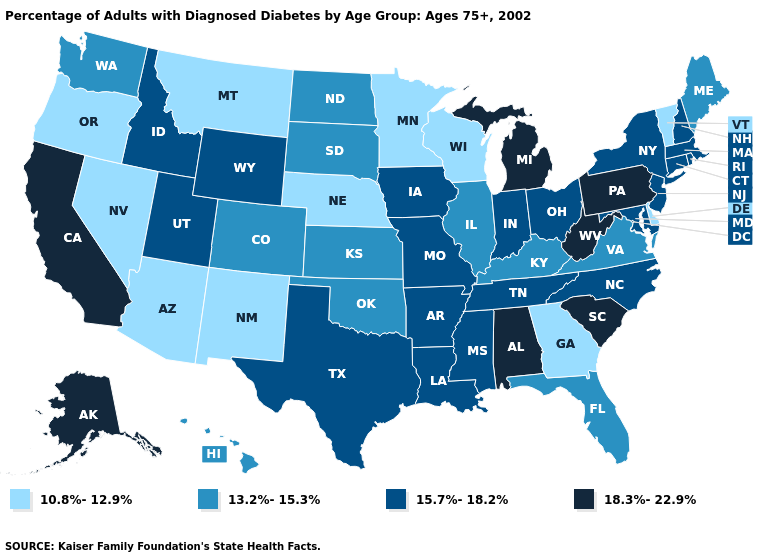Which states have the lowest value in the USA?
Quick response, please. Arizona, Delaware, Georgia, Minnesota, Montana, Nebraska, Nevada, New Mexico, Oregon, Vermont, Wisconsin. Which states have the lowest value in the MidWest?
Be succinct. Minnesota, Nebraska, Wisconsin. Name the states that have a value in the range 18.3%-22.9%?
Be succinct. Alabama, Alaska, California, Michigan, Pennsylvania, South Carolina, West Virginia. Which states hav the highest value in the MidWest?
Write a very short answer. Michigan. What is the value of New Hampshire?
Concise answer only. 15.7%-18.2%. How many symbols are there in the legend?
Give a very brief answer. 4. What is the value of Florida?
Short answer required. 13.2%-15.3%. What is the value of New Mexico?
Answer briefly. 10.8%-12.9%. What is the lowest value in states that border California?
Be succinct. 10.8%-12.9%. Among the states that border Massachusetts , does Connecticut have the highest value?
Be succinct. Yes. Does the first symbol in the legend represent the smallest category?
Quick response, please. Yes. Does Iowa have the lowest value in the MidWest?
Give a very brief answer. No. Name the states that have a value in the range 10.8%-12.9%?
Concise answer only. Arizona, Delaware, Georgia, Minnesota, Montana, Nebraska, Nevada, New Mexico, Oregon, Vermont, Wisconsin. Name the states that have a value in the range 15.7%-18.2%?
Be succinct. Arkansas, Connecticut, Idaho, Indiana, Iowa, Louisiana, Maryland, Massachusetts, Mississippi, Missouri, New Hampshire, New Jersey, New York, North Carolina, Ohio, Rhode Island, Tennessee, Texas, Utah, Wyoming. 